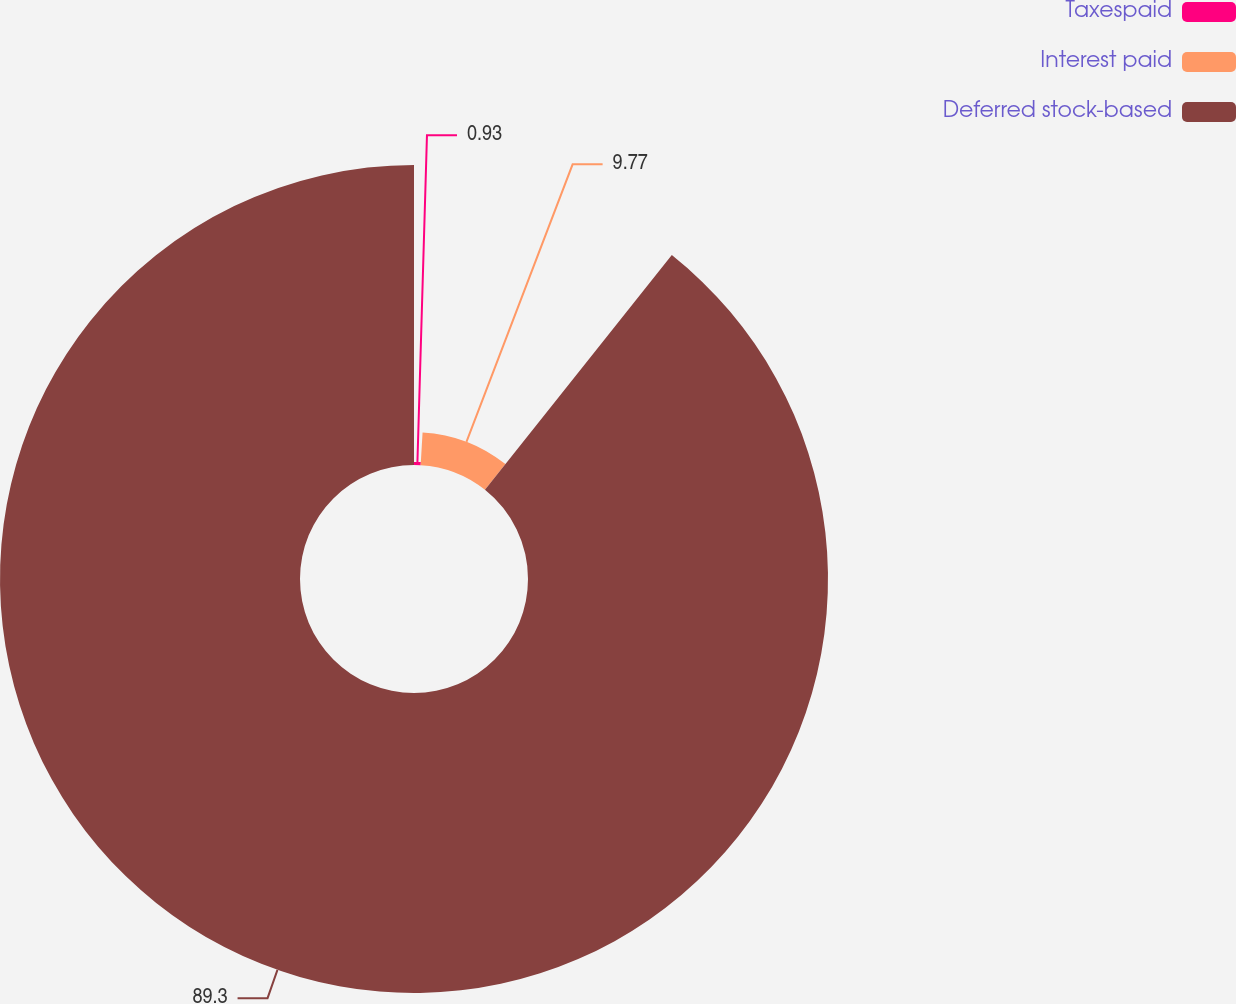Convert chart to OTSL. <chart><loc_0><loc_0><loc_500><loc_500><pie_chart><fcel>Taxespaid<fcel>Interest paid<fcel>Deferred stock-based<nl><fcel>0.93%<fcel>9.77%<fcel>89.31%<nl></chart> 